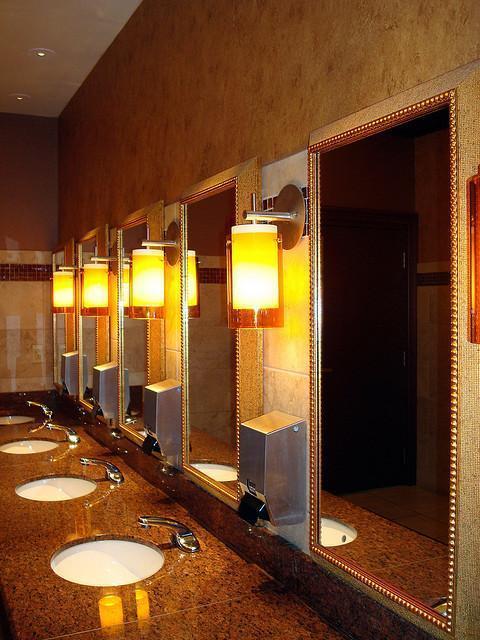How many lights are on?
Give a very brief answer. 4. How many horses are depicted?
Give a very brief answer. 0. 